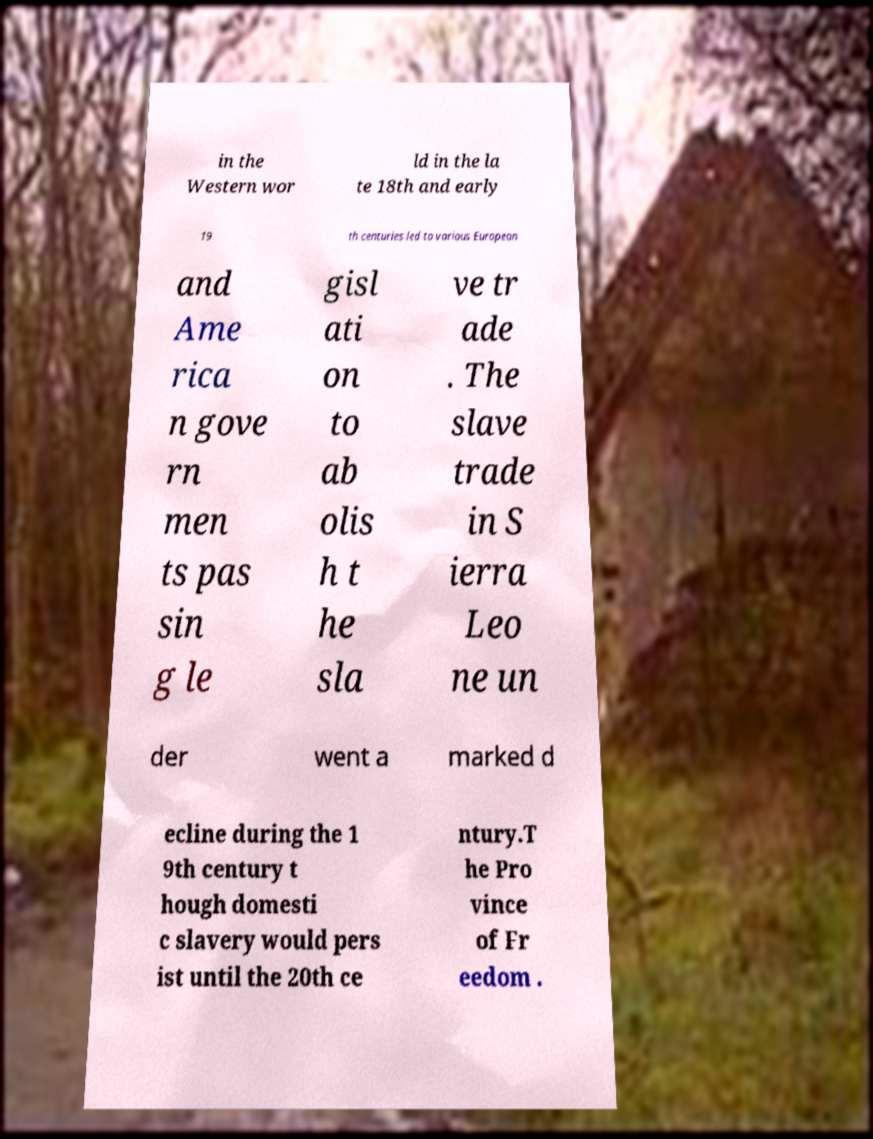Can you read and provide the text displayed in the image?This photo seems to have some interesting text. Can you extract and type it out for me? in the Western wor ld in the la te 18th and early 19 th centuries led to various European and Ame rica n gove rn men ts pas sin g le gisl ati on to ab olis h t he sla ve tr ade . The slave trade in S ierra Leo ne un der went a marked d ecline during the 1 9th century t hough domesti c slavery would pers ist until the 20th ce ntury.T he Pro vince of Fr eedom . 